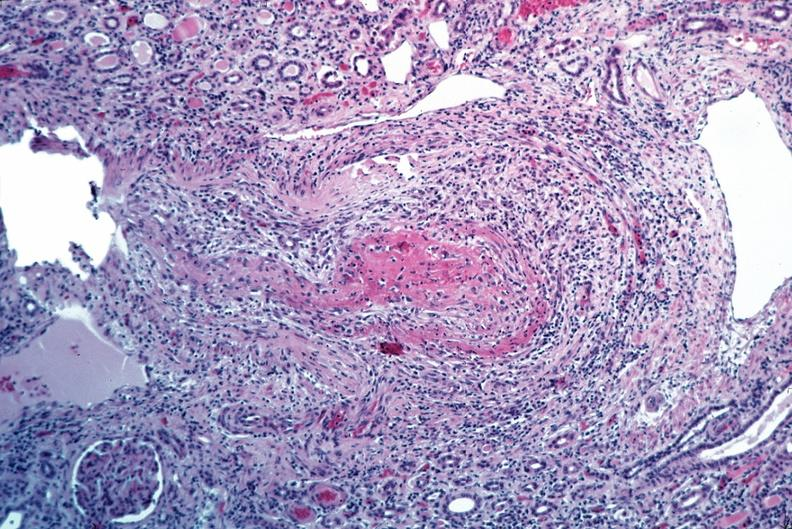what is present?
Answer the question using a single word or phrase. Vasculature 